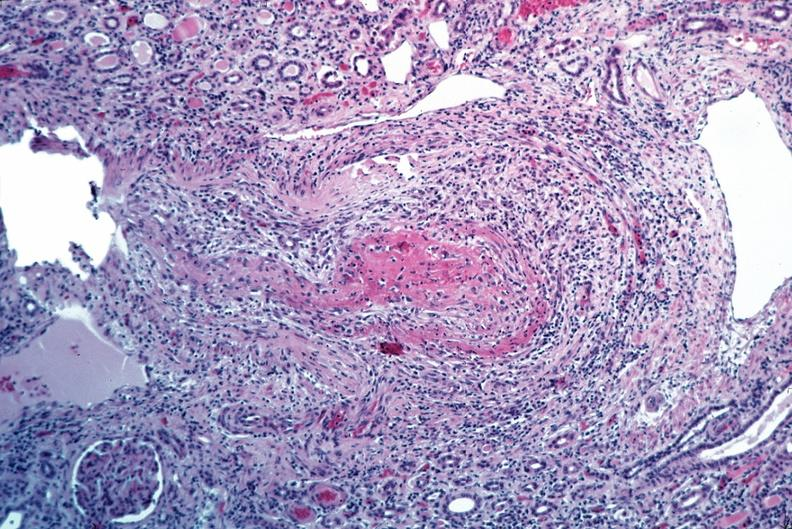what is present?
Answer the question using a single word or phrase. Vasculature 